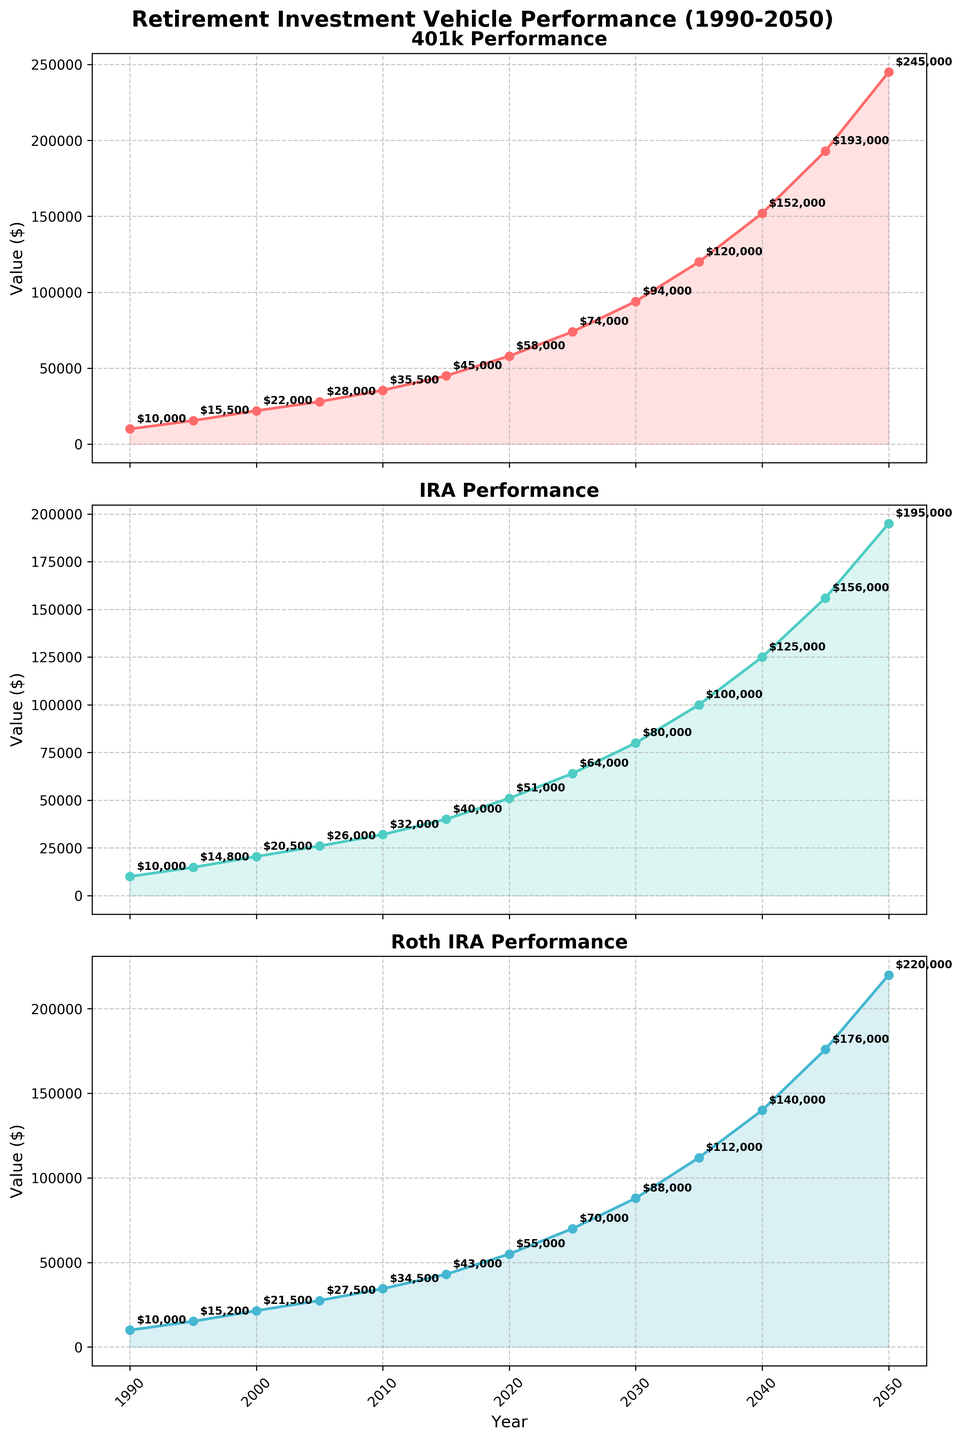what is the maximum value for each investment vehicle by 2050? From the highest point on the lines in the plots, you can see the values for 2050 are: 401k reaches $245,000, IRA reaches $195,000, and Roth IRA reaches $220,000
Answer: 401k: $245,000, IRA: $195,000, Roth IRA: $220,000 which investment vehicle has the least growth between 2010 and 2020? By comparing the difference in values between 2010 and 2020 for each vehicle: 401k increases from $35,500 to $58,000 (a difference of $22,500), IRA grows from $32,000 to $51,000 ($19,000), and Roth IRA grows from $34,500 to $55,000 ($20,500)
Answer: IRA how does the value of Roth IRA in 2040 compare to IRA in the same year? Observing the values for the year 2040 in the plots, Roth IRA reaches $140,000 whereas IRA reaches $125,000
Answer: Roth IRA is $15,000 higher than IRA in 2040 what is the average value of the 401k over the 30-year period? Summing the values of 401k from 1990 to 2050 and dividing by the number of data points gives the average: ($10,000 + $15,500 + $22,000 + $28,000 + $35,500 + $45,000 + $58,000 + $74,000 + $94,000 + $120,000 + $152,000 + $193,000 + $245,000) / 13 = $84,692
Answer: $84,692 which investment vehicle shows the largest value increase between 2030 and 2040? The increase is found by subtracting the 2030 value from the 2040 value for each vehicle: 401k ($152,000 - $94,000 = $58,000), IRA ($125,000 - $80,000 = $45,000), and Roth IRA ($140,000 - $88,000 = $52,000)
Answer: 401k which years show a growth exceeding $20,000 for 401k investments? By examining the points and noticing the differences that exceed $20,000: between 2040 and 2050 ($40,000), 2035 and 2040 ($32,000), 2030 and 2035 ($26,000), 2025 and 2030 ($20,000)
Answer: 2025-2030, 2030-2035, 2035-2040, 2040-2050 which investment vehicle has the steepest growth curve visually? By looking at the plots and noticing which one has the visually steepest incline across multiple segments, the 401k shows a steeper overall trend, especially from 2030 onwards
Answer: 401k what is the value difference between IRA and Roth IRA in 2025? Observing the points for 2025, IRA at $64,000 and Roth IRA at $70,000, the difference is $70,000 - $64,000
Answer: $6,000 